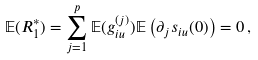<formula> <loc_0><loc_0><loc_500><loc_500>{ \mathbb { E } } ( R _ { 1 } ^ { \ast } ) = \sum _ { j = 1 } ^ { p } { \mathbb { E } } ( g _ { i u } ^ { ( j ) } ) { \mathbb { E } } \left ( \partial _ { j } s _ { i u } ( { 0 } ) \right ) = 0 \, ,</formula> 